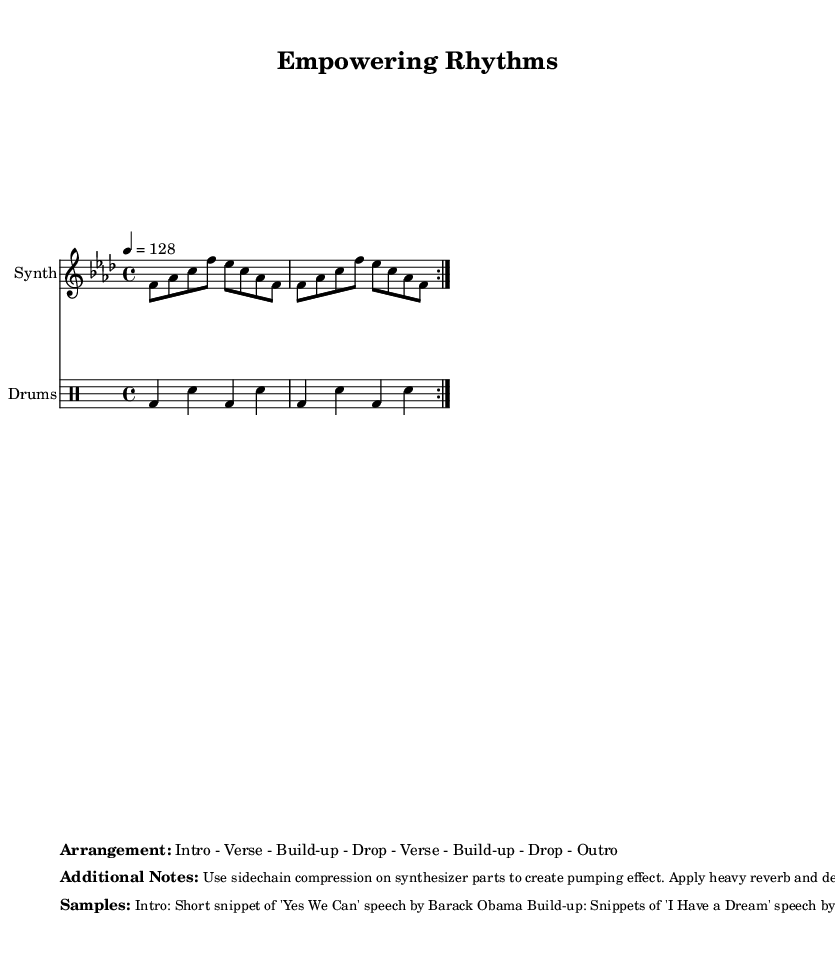What is the key signature of this music? The key signature indicates that the piece is in F minor, which includes four flats. This can be deduced from the global setup in the code.
Answer: F minor What is the time signature of this piece? The time signature shows that the piece is set in 4/4, meaning there are four beats in each measure and the quarter note receives one beat. This is specified in the global section of the code.
Answer: 4/4 What is the tempo marking for this music? The tempo marking states that the tempo is set at 128 beats per minute. This is clearly stated in the global section.
Answer: 128 How many times does the melody repeat in the score? The melody is indicated to repeat twice as per the volta notation in the synth melody. This is noted in the repeated section of the code.
Answer: 2 What is the instrument name for the synthesized part? The instrument name for the synthesized part is specified as “Synth” in the score configuration. This is defined in the Staff creation in the code.
Answer: Synth What type of speech sample is used for the intro? The intro uses a short snippet of Barack Obama's "Yes We Can" speech, as noted in the additional notes section of the markup.
Answer: Yes We Can What is the structural arrangement of the piece? The structural arrangement is outlined as Intro - Verse - Build-up - Drop - Verse - Build-up - Drop - Outro. This is explicitly listed in the markup section of the provided code.
Answer: Intro - Verse - Build-up - Drop - Verse - Build-up - Drop - Outro 